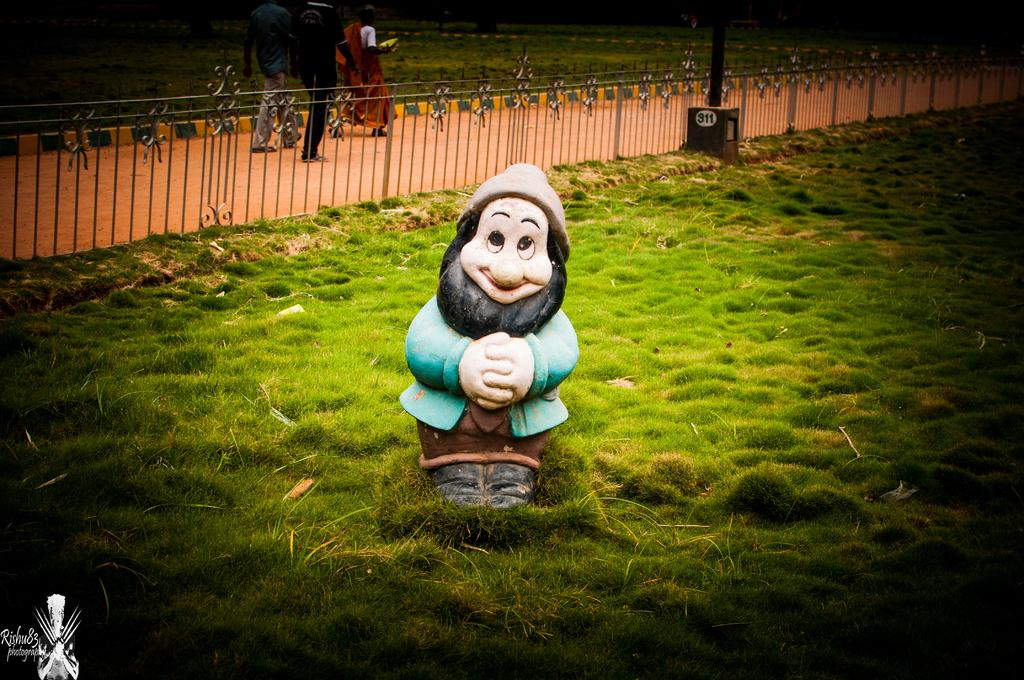What is on the ground in the image? There is a toy on the ground in the image. What type of barrier is visible in the image? There is a fence in the image. What vertical structure can be seen in the image? There is a pole in the image. What are the people in the image doing? People are walking on the road in the image. How many arms are visible on the toy in the image? There is no information about the toy's arms in the image, as it is not mentioned in the provided facts. What order are the people walking in on the road in the image? There is no information about the order in which the people are walking on the road in the image, as it is not mentioned in the provided facts. 